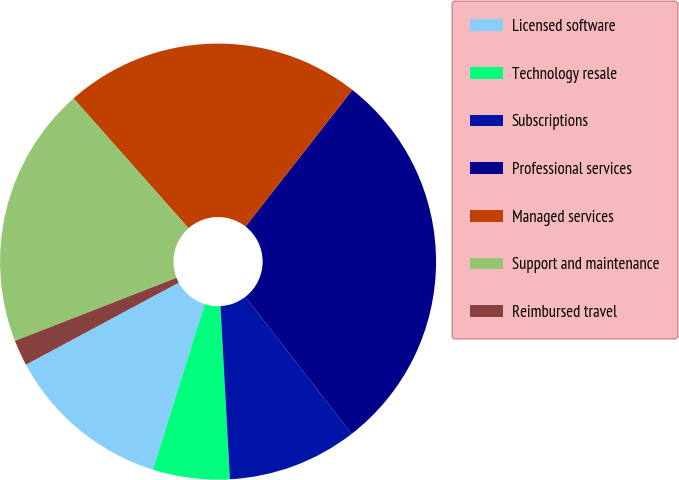Convert chart to OTSL. <chart><loc_0><loc_0><loc_500><loc_500><pie_chart><fcel>Licensed software<fcel>Technology resale<fcel>Subscriptions<fcel>Professional services<fcel>Managed services<fcel>Support and maintenance<fcel>Reimbursed travel<nl><fcel>12.33%<fcel>5.7%<fcel>9.63%<fcel>28.94%<fcel>22.1%<fcel>19.39%<fcel>1.91%<nl></chart> 